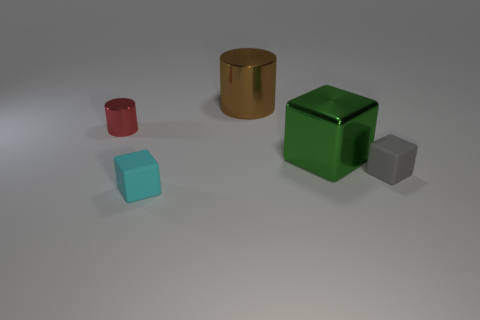Subtract all big cubes. How many cubes are left? 2 Subtract all cyan cubes. How many cubes are left? 2 Add 2 tiny gray things. How many objects exist? 7 Subtract all cylinders. How many objects are left? 3 Add 3 large brown shiny cylinders. How many large brown shiny cylinders are left? 4 Add 1 large yellow metal blocks. How many large yellow metal blocks exist? 1 Subtract 0 blue cubes. How many objects are left? 5 Subtract all red cubes. Subtract all blue balls. How many cubes are left? 3 Subtract all red metal cubes. Subtract all cyan rubber cubes. How many objects are left? 4 